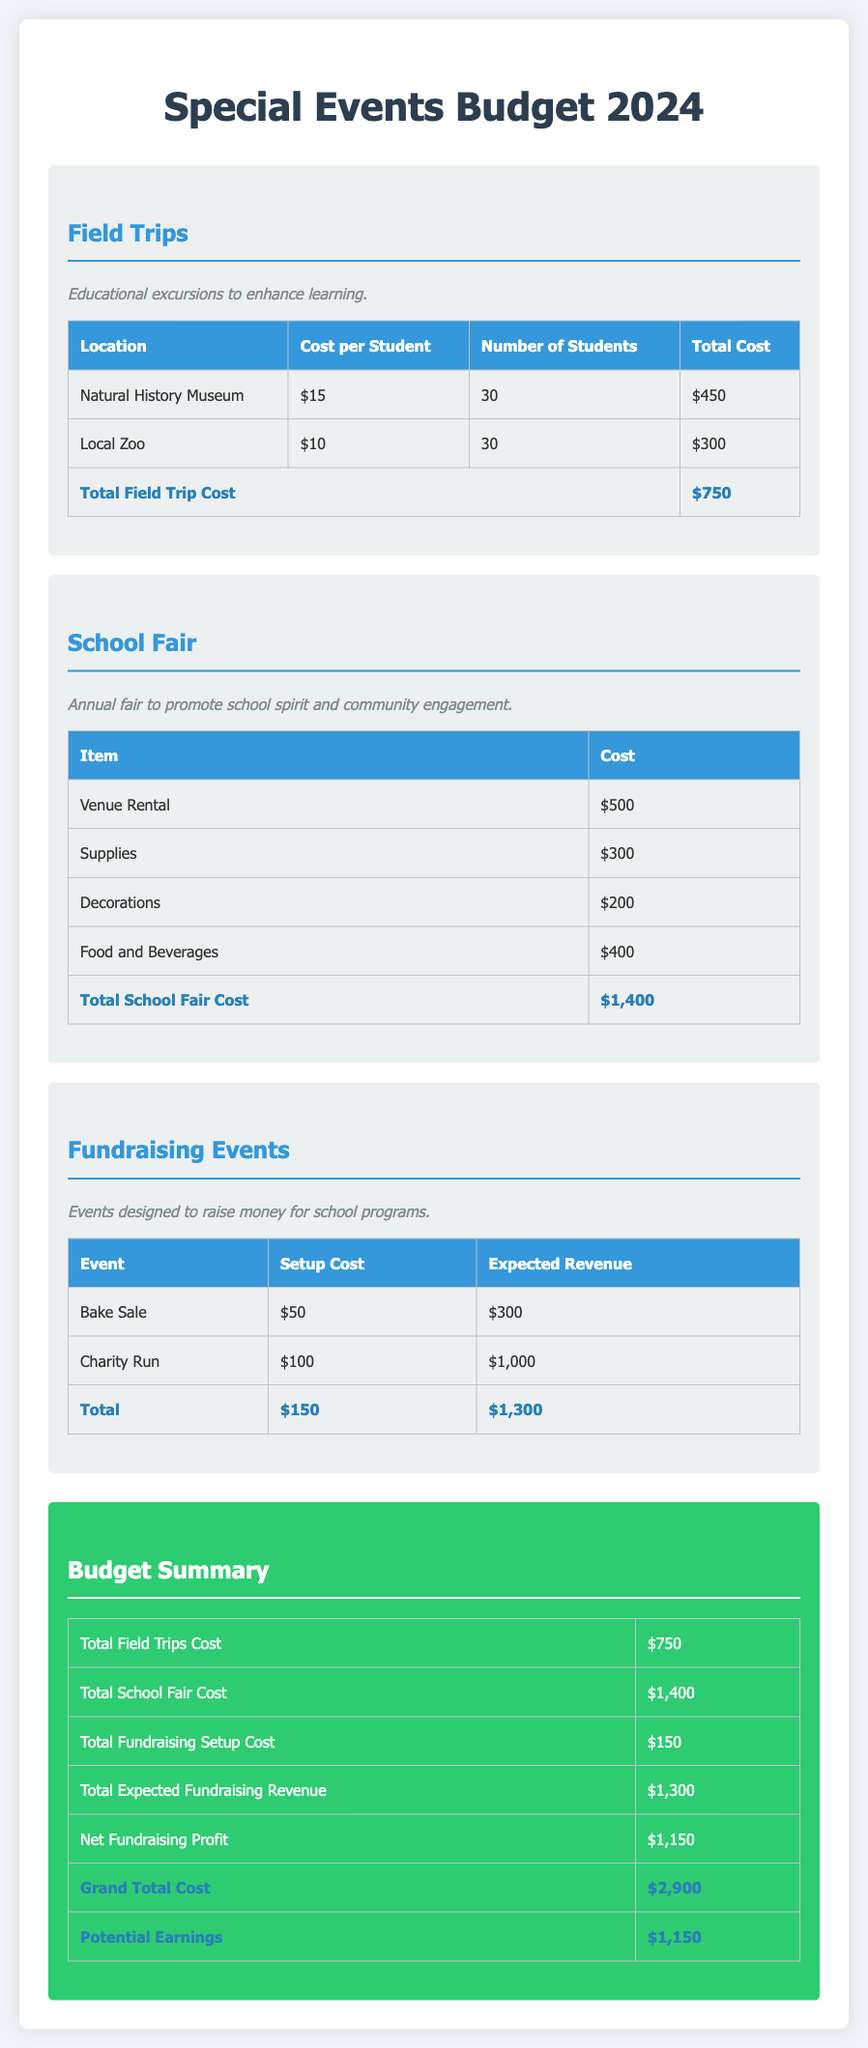What is the total cost for field trips? The document lists the total cost for field trips, which is $750.
Answer: $750 What are the expected earnings from fundraising events? The expected earnings from fundraising events are summed in the document, which is $1,300.
Answer: $1,300 How much does it cost to rent the venue for the school fair? The document specifies that the venue rental cost is $500.
Answer: $500 What is the net fundraising profit? The net fundraising profit is calculated by subtracting the total setup cost from the expected revenue, resulting in $1,150.
Answer: $1,150 What are the total costs for the school fair? The total costs for the school fair are summed up in the document as $1,400.
Answer: $1,400 What is the total number of students for field trips? The total number of students for field trips mentioned in the document is 60.
Answer: 60 What is the total cost for food and beverages at the school fair? The document states that the total cost for food and beverages is $400.
Answer: $400 What is the total amount spent on supplies for the school fair? The total amount spent on supplies for the school fair is outlined in the document as $300.
Answer: $300 What is the grand total cost for all events? The grand total cost for all events is clearly stated in the document as $2,900.
Answer: $2,900 